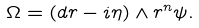<formula> <loc_0><loc_0><loc_500><loc_500>\Omega = ( d r - i \eta ) \wedge r ^ { n } \psi .</formula> 